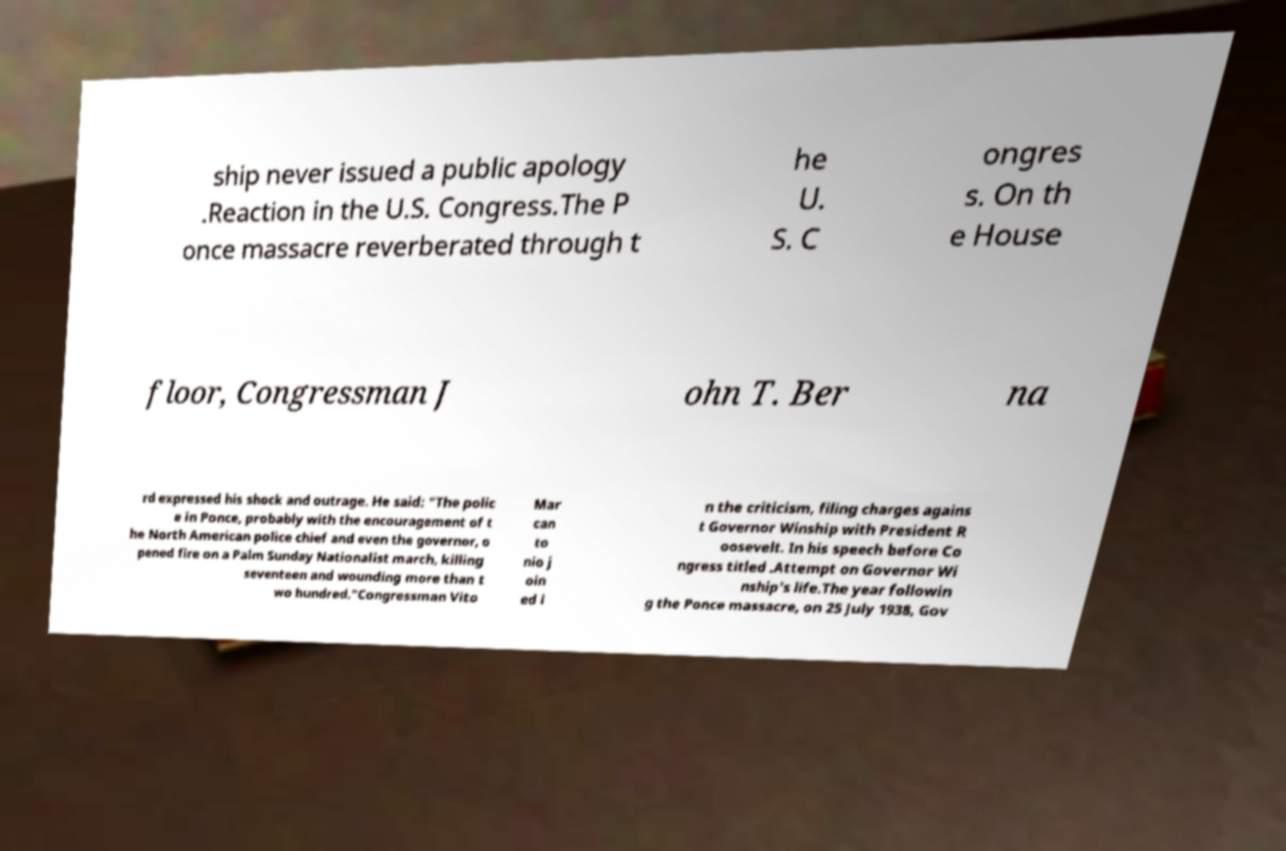There's text embedded in this image that I need extracted. Can you transcribe it verbatim? ship never issued a public apology .Reaction in the U.S. Congress.The P once massacre reverberated through t he U. S. C ongres s. On th e House floor, Congressman J ohn T. Ber na rd expressed his shock and outrage. He said: "The polic e in Ponce, probably with the encouragement of t he North American police chief and even the governor, o pened fire on a Palm Sunday Nationalist march, killing seventeen and wounding more than t wo hundred."Congressman Vito Mar can to nio j oin ed i n the criticism, filing charges agains t Governor Winship with President R oosevelt. In his speech before Co ngress titled .Attempt on Governor Wi nship's life.The year followin g the Ponce massacre, on 25 July 1938, Gov 